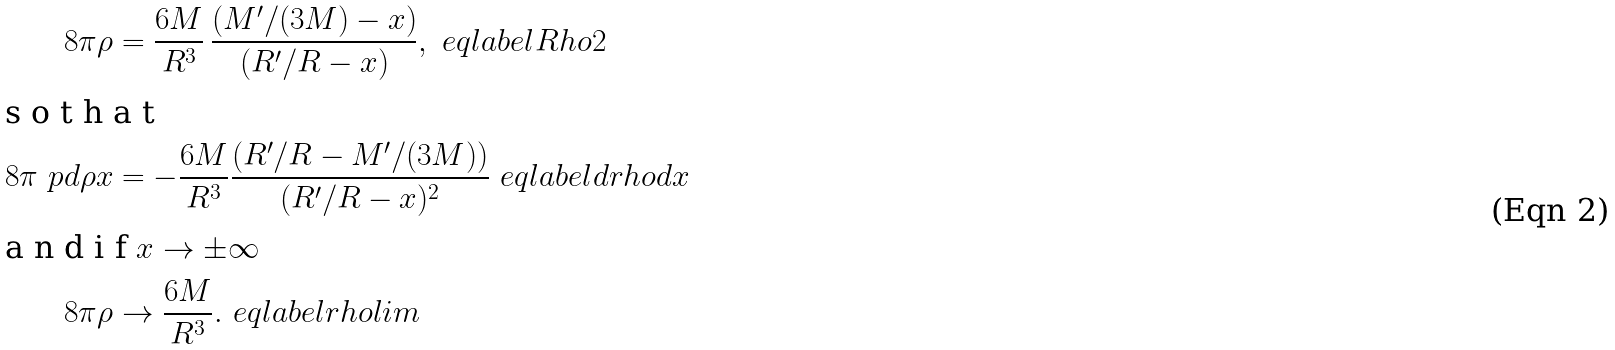<formula> <loc_0><loc_0><loc_500><loc_500>8 \pi \rho & = \frac { 6 M } { R ^ { 3 } } \, \frac { ( M ^ { \prime } / ( 3 M ) - x ) } { ( R ^ { \prime } / R - x ) } , \ e q l a b e l { R h o 2 } \intertext { s o t h a t } 8 \pi \ p d { \rho } { x } & = - \frac { 6 M } { R ^ { 3 } } \frac { ( R ^ { \prime } / R - M ^ { \prime } / ( 3 M ) ) } { ( R ^ { \prime } / R - x ) ^ { 2 } } \ e q l a b e l { d r h o d x } \intertext { a n d i f $ x \to \pm \infty $ } 8 \pi \rho & \to \frac { 6 M } { R ^ { 3 } } . \ e q l a b e l { r h o l i m }</formula> 